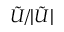<formula> <loc_0><loc_0><loc_500><loc_500>\tilde { U } / | \tilde { U } |</formula> 